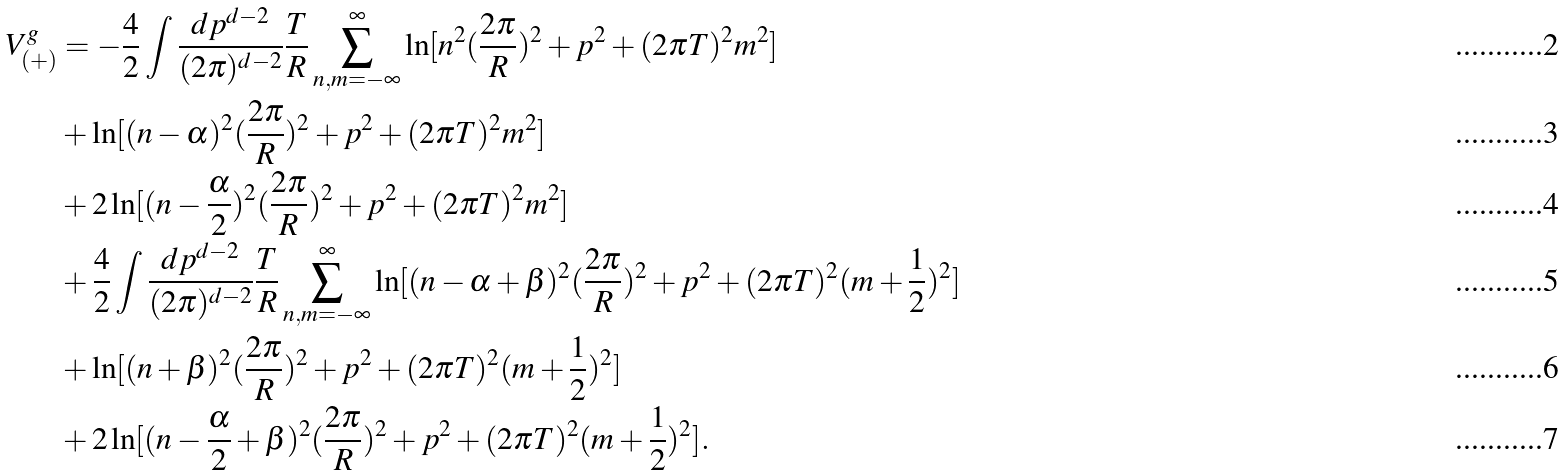<formula> <loc_0><loc_0><loc_500><loc_500>V _ { ( + ) } ^ { g } & = - \frac { 4 } { 2 } \int \frac { d p ^ { d - 2 } } { ( 2 \pi ) ^ { d - 2 } } \frac { T } { R } \sum _ { n , m = - \infty } ^ { \infty } \ln [ n ^ { 2 } ( \frac { 2 \pi } { R } ) ^ { 2 } + p ^ { 2 } + ( 2 \pi { T } ) ^ { 2 } m ^ { 2 } ] \\ & + \ln [ ( n - \alpha ) ^ { 2 } ( \frac { 2 \pi } { R } ) ^ { 2 } + p ^ { 2 } + ( 2 \pi { T } ) ^ { 2 } m ^ { 2 } ] \\ & + 2 \ln [ ( n - \frac { \alpha } { 2 } ) ^ { 2 } ( \frac { 2 \pi } { R } ) ^ { 2 } + p ^ { 2 } + ( 2 \pi { T } ) ^ { 2 } m ^ { 2 } ] \\ & + \frac { 4 } { 2 } \int \frac { d p ^ { d - 2 } } { ( 2 \pi ) ^ { d - 2 } } \frac { T } { R } \sum _ { n , m = - \infty } ^ { \infty } \ln [ ( n - \alpha + \beta ) ^ { 2 } ( \frac { 2 \pi } { R } ) ^ { 2 } + p ^ { 2 } + ( 2 \pi { T } ) ^ { 2 } ( m + \frac { 1 } { 2 } ) ^ { 2 } ] \\ & + \ln [ ( n + \beta ) ^ { 2 } ( \frac { 2 \pi } { R } ) ^ { 2 } + p ^ { 2 } + ( 2 \pi { T } ) ^ { 2 } ( m + \frac { 1 } { 2 } ) ^ { 2 } ] \\ & + 2 \ln [ ( n - \frac { \alpha } { 2 } + \beta ) ^ { 2 } ( \frac { 2 \pi } { R } ) ^ { 2 } + p ^ { 2 } + ( 2 \pi { T } ) ^ { 2 } ( m + \frac { 1 } { 2 } ) ^ { 2 } ] .</formula> 